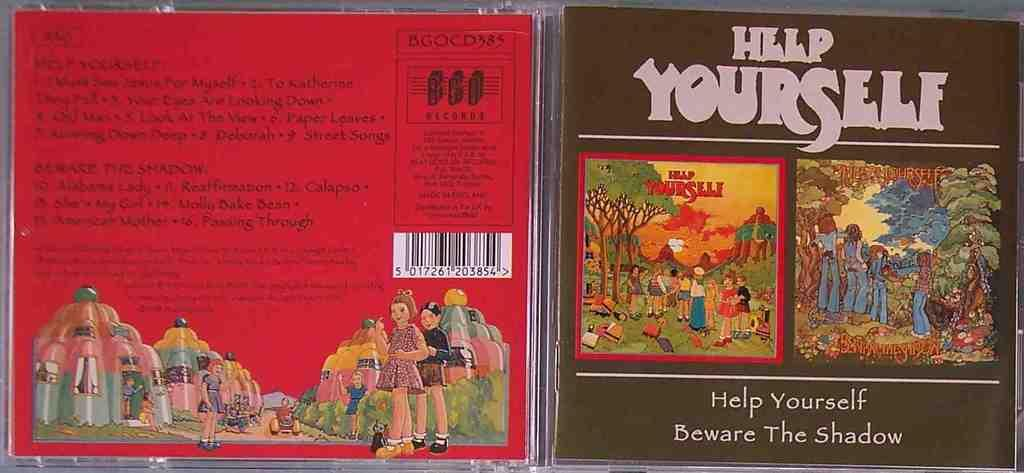<image>
Render a clear and concise summary of the photo. A CD case is open and is titled Help Yourself. 